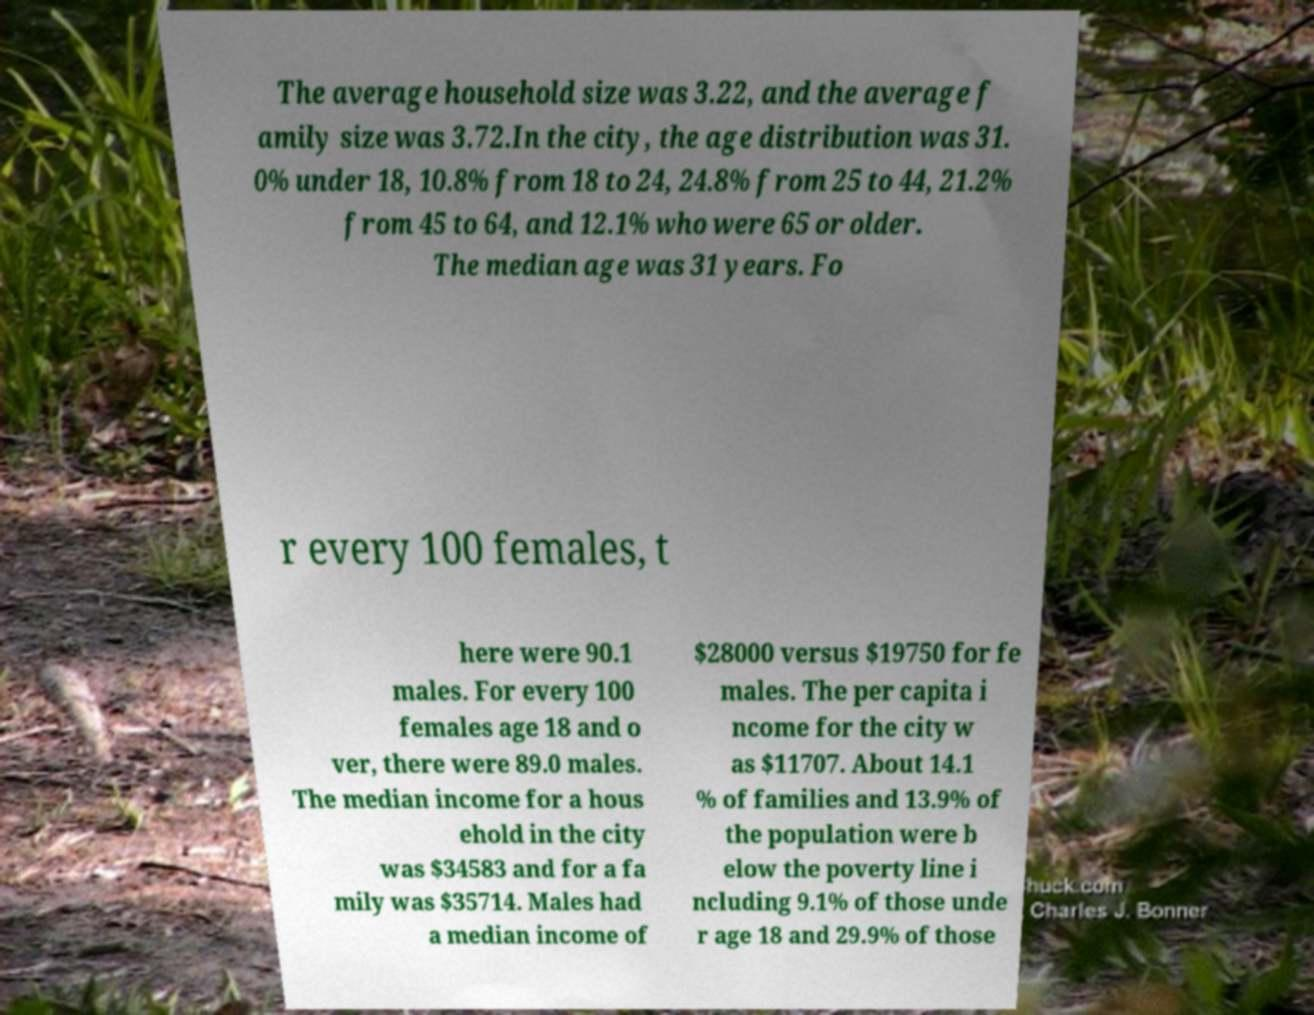Could you extract and type out the text from this image? The average household size was 3.22, and the average f amily size was 3.72.In the city, the age distribution was 31. 0% under 18, 10.8% from 18 to 24, 24.8% from 25 to 44, 21.2% from 45 to 64, and 12.1% who were 65 or older. The median age was 31 years. Fo r every 100 females, t here were 90.1 males. For every 100 females age 18 and o ver, there were 89.0 males. The median income for a hous ehold in the city was $34583 and for a fa mily was $35714. Males had a median income of $28000 versus $19750 for fe males. The per capita i ncome for the city w as $11707. About 14.1 % of families and 13.9% of the population were b elow the poverty line i ncluding 9.1% of those unde r age 18 and 29.9% of those 